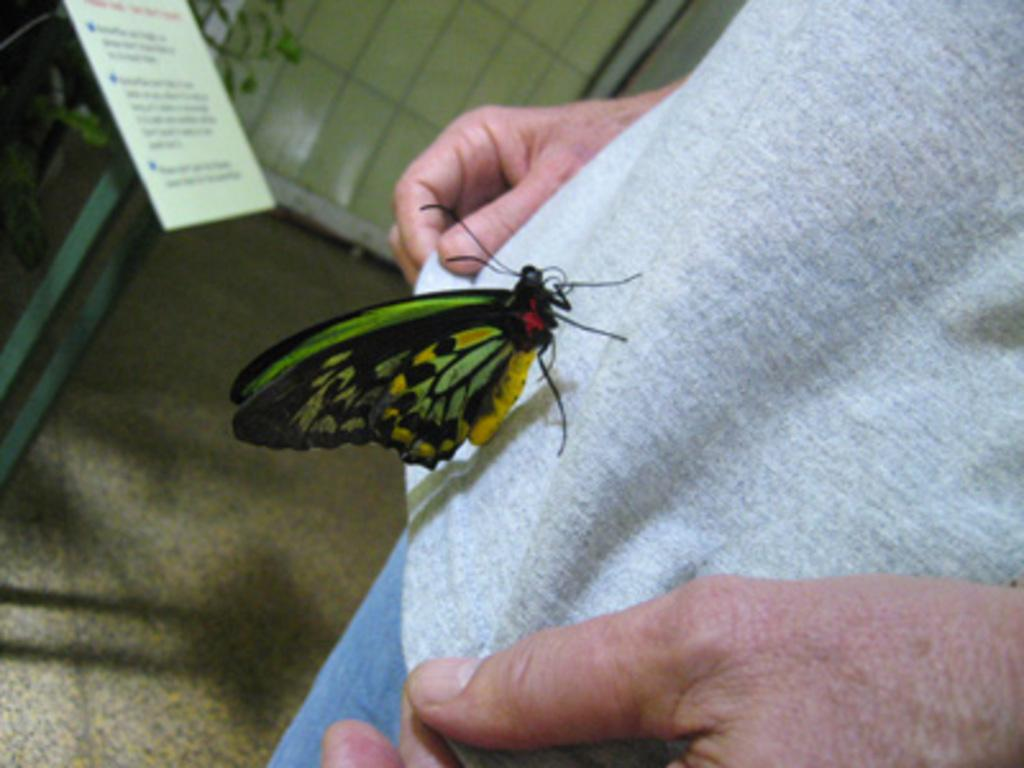What is on the person's dress in the image? There is a butterfly on the person's dress in the image. What can be seen on the whiteboard in the image? There is text visible on a whiteboard in the image. What type of wall is in the background of the image? There is a tile wall in the background of the image. What is the government's stance on the butterfly's income in the image? There is no information about the government or the butterfly's income in the image. The image only shows a butterfly on a person's dress and text on a whiteboard. 